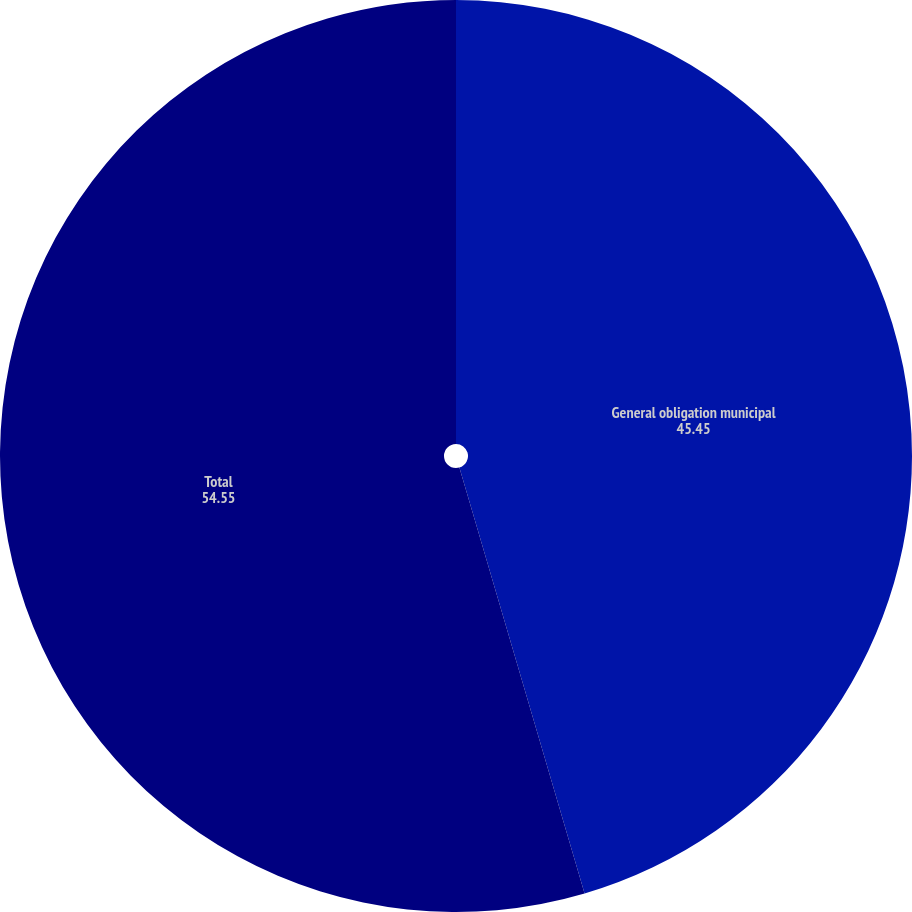<chart> <loc_0><loc_0><loc_500><loc_500><pie_chart><fcel>General obligation municipal<fcel>Total<nl><fcel>45.45%<fcel>54.55%<nl></chart> 